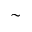Convert formula to latex. <formula><loc_0><loc_0><loc_500><loc_500>\sim</formula> 